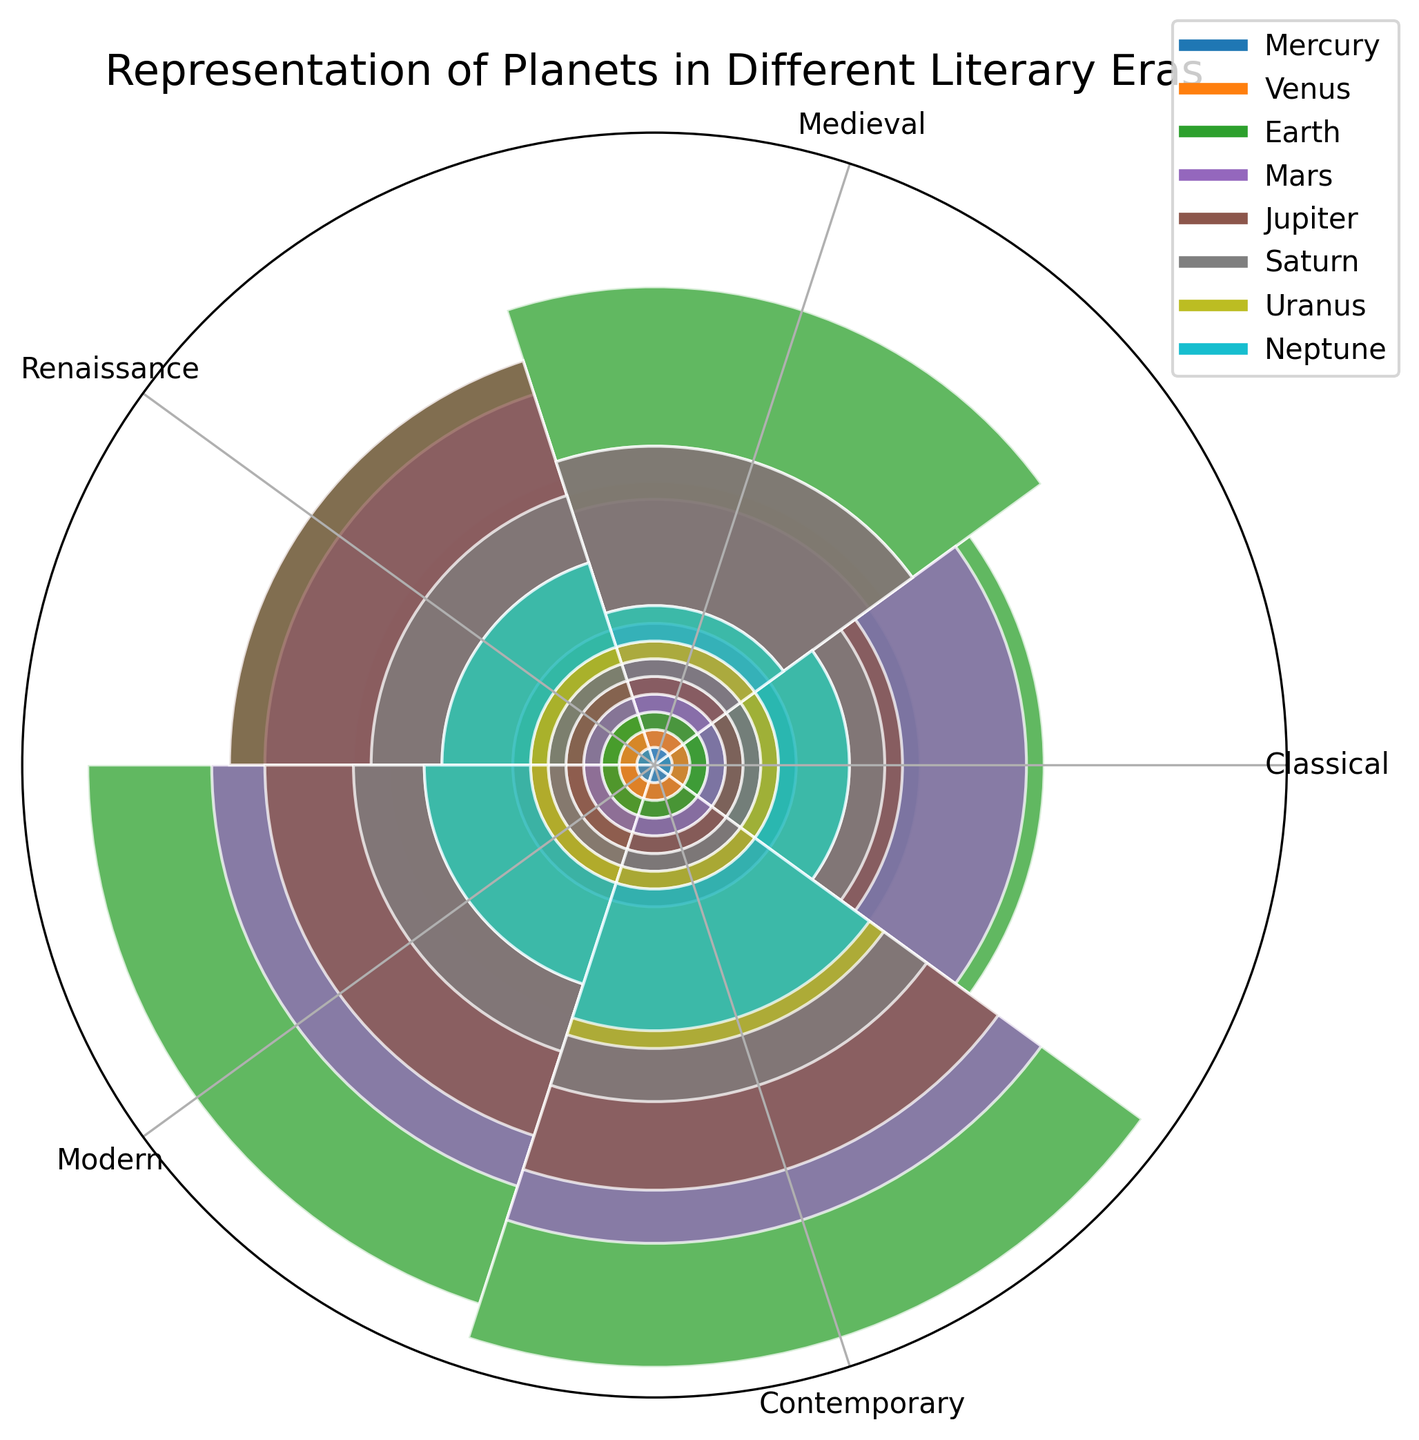What is the most frequently represented planet in the Classical era? By looking at the figure, identify which planet's section within the Classical era has the largest area. This corresponds to the highest count. Earth has the largest area in the Classical era.
Answer: Earth Which planet's representation increased the most from the Medieval to the Renaissance era? To find the answer, compare the area sizes of planets between the Medieval and Renaissance eras and note the planet with the greatest increase in area. Jupiter's representation shows the largest increase from the Medieval to the Renaissance era.
Answer: Jupiter What is the total count of representations for Mars across all eras? Sum the counts of Mars from Classical, Medieval, Renaissance, Modern, and Contemporary eras (18 + 12 + 19 + 22 + 24) to find the total representation count.
Answer: 95 Which era has the least representation for Neptune? By examining the smallest area allocated to Neptune in all the eras, determine the era with the smallest representation count for Neptune. The Medieval era has the least representation for Neptune.
Answer: Medieval Which planet shows a steadily increasing representation through all eras? Check the areas for each planet across all eras. The planet with consistently increasing area from Classical to Contemporary is the one with steadily increasing representation. Earth's representation increases steadily across all eras.
Answer: Earth How does the representation of Saturn in the Modern era compare to the Contemporary era? Compare the areas allotted to Saturn in the Modern and Contemporary eras to see which is larger. The size in the Contemporary era is slightly larger than in the Modern era, indicating an increase.
Answer: Larger What is the average representation count for Venus across all eras? To find the average, sum the counts of Venus from all eras (12 + 15 + 16 + 14 + 18) and divide by the number of eras (5). The sum is 75, so the average is 75/5 = 15.
Answer: 15 What is the difference in representation of Jupiter between the Classical and Contemporary eras? Subtract the representation count of Jupiter in the Classical era from the count in the Contemporary era (20 - 10). The difference is 10.
Answer: 10 Which planet's representation decreased in the Contemporary era compared to the Modern era? Compare the representation counts for all planets between the Modern and Contemporary eras to identify which planet shows a decrease. Mercury's representation decreased from 13 in the Modern era to 12 in the Contemporary era.
Answer: Mercury 